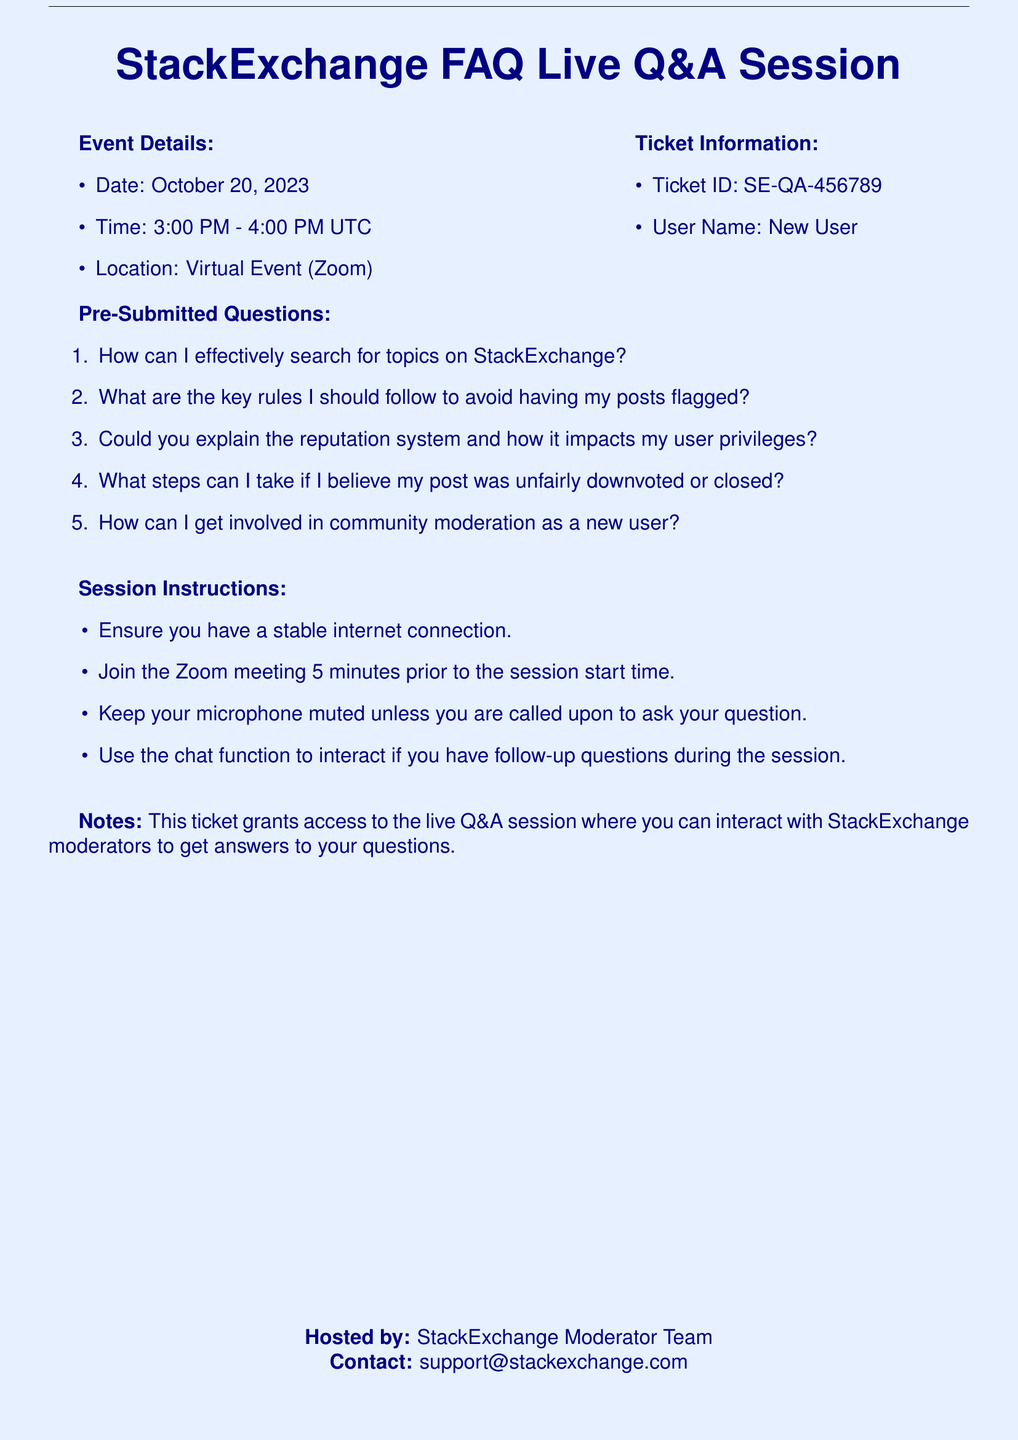What is the date of the session? The date of the session is specified in the document, which is October 20, 2023.
Answer: October 20, 2023 What time does the session start? The start time of the session is mentioned in the document, which states 3:00 PM UTC.
Answer: 3:00 PM What is the Ticket ID? The Ticket ID is provided in the Ticket section of the document, which is SE-QA-456789.
Answer: SE-QA-456789 How long is the session? The duration of the session can be inferred from the start and end times listed in the document, which indicates a one-hour session.
Answer: 1 hour Which platform is being used for the event? The platform for the event is mentioned in the document as a Virtual Event using Zoom.
Answer: Zoom What is one of the pre-submitted questions listed? The document contains a list of pre-submitted questions, one of which is about searching for topics.
Answer: How can I effectively search for topics on StackExchange? Who is hosting the event? The document states the event is hosted by the StackExchange Moderator Team.
Answer: StackExchange Moderator Team What should participants do 5 minutes before the session? Instructions in the document specify that participants should join the Zoom meeting 5 minutes prior to the session.
Answer: Join the Zoom meeting How can users interact during the session? The document provides instructions on interaction during the session, suggesting the use of the chat function for follow-up questions.
Answer: Use the chat function 